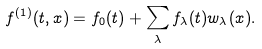<formula> <loc_0><loc_0><loc_500><loc_500>f ^ { ( 1 ) } ( t , x ) = f _ { 0 } ( t ) + \sum _ { \lambda } f _ { \lambda } ( t ) w _ { \lambda } ( x ) .</formula> 